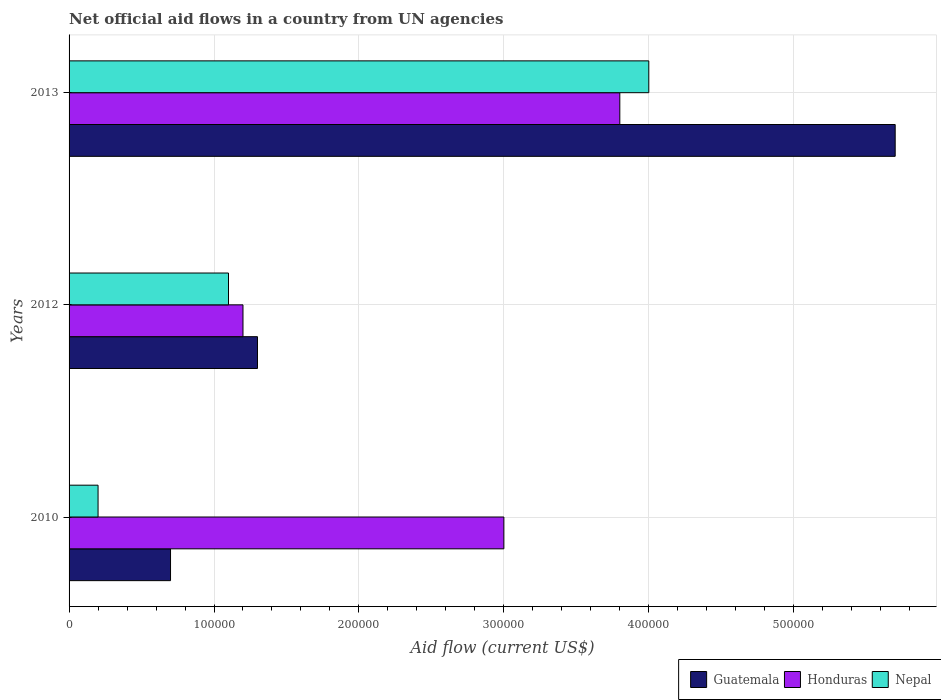How many different coloured bars are there?
Keep it short and to the point. 3. How many groups of bars are there?
Provide a short and direct response. 3. Are the number of bars on each tick of the Y-axis equal?
Give a very brief answer. Yes. How many bars are there on the 1st tick from the bottom?
Keep it short and to the point. 3. What is the label of the 2nd group of bars from the top?
Give a very brief answer. 2012. In how many cases, is the number of bars for a given year not equal to the number of legend labels?
Provide a succinct answer. 0. What is the net official aid flow in Guatemala in 2012?
Provide a short and direct response. 1.30e+05. Across all years, what is the maximum net official aid flow in Nepal?
Keep it short and to the point. 4.00e+05. Across all years, what is the minimum net official aid flow in Honduras?
Provide a short and direct response. 1.20e+05. In which year was the net official aid flow in Nepal maximum?
Your response must be concise. 2013. In which year was the net official aid flow in Honduras minimum?
Provide a short and direct response. 2012. What is the total net official aid flow in Honduras in the graph?
Your response must be concise. 8.00e+05. What is the difference between the net official aid flow in Guatemala in 2010 and that in 2013?
Your answer should be compact. -5.00e+05. What is the difference between the net official aid flow in Guatemala in 2010 and the net official aid flow in Honduras in 2012?
Your response must be concise. -5.00e+04. What is the average net official aid flow in Nepal per year?
Give a very brief answer. 1.77e+05. In the year 2013, what is the difference between the net official aid flow in Guatemala and net official aid flow in Honduras?
Provide a short and direct response. 1.90e+05. What is the ratio of the net official aid flow in Nepal in 2010 to that in 2012?
Offer a very short reply. 0.18. Is the difference between the net official aid flow in Guatemala in 2010 and 2012 greater than the difference between the net official aid flow in Honduras in 2010 and 2012?
Ensure brevity in your answer.  No. What is the difference between the highest and the second highest net official aid flow in Nepal?
Offer a very short reply. 2.90e+05. What is the difference between the highest and the lowest net official aid flow in Guatemala?
Offer a terse response. 5.00e+05. Is the sum of the net official aid flow in Honduras in 2010 and 2013 greater than the maximum net official aid flow in Nepal across all years?
Ensure brevity in your answer.  Yes. What does the 1st bar from the top in 2012 represents?
Your answer should be very brief. Nepal. What does the 1st bar from the bottom in 2010 represents?
Provide a short and direct response. Guatemala. How many bars are there?
Your response must be concise. 9. Are all the bars in the graph horizontal?
Make the answer very short. Yes. How many years are there in the graph?
Ensure brevity in your answer.  3. Are the values on the major ticks of X-axis written in scientific E-notation?
Your response must be concise. No. Does the graph contain any zero values?
Make the answer very short. No. Where does the legend appear in the graph?
Your answer should be very brief. Bottom right. How are the legend labels stacked?
Offer a terse response. Horizontal. What is the title of the graph?
Ensure brevity in your answer.  Net official aid flows in a country from UN agencies. What is the label or title of the Y-axis?
Keep it short and to the point. Years. What is the Aid flow (current US$) in Guatemala in 2010?
Make the answer very short. 7.00e+04. What is the Aid flow (current US$) in Guatemala in 2012?
Your answer should be very brief. 1.30e+05. What is the Aid flow (current US$) in Nepal in 2012?
Your response must be concise. 1.10e+05. What is the Aid flow (current US$) of Guatemala in 2013?
Provide a short and direct response. 5.70e+05. What is the Aid flow (current US$) in Nepal in 2013?
Give a very brief answer. 4.00e+05. Across all years, what is the maximum Aid flow (current US$) in Guatemala?
Your answer should be compact. 5.70e+05. Across all years, what is the maximum Aid flow (current US$) in Nepal?
Make the answer very short. 4.00e+05. Across all years, what is the minimum Aid flow (current US$) of Honduras?
Your response must be concise. 1.20e+05. What is the total Aid flow (current US$) of Guatemala in the graph?
Provide a short and direct response. 7.70e+05. What is the total Aid flow (current US$) of Nepal in the graph?
Your response must be concise. 5.30e+05. What is the difference between the Aid flow (current US$) in Honduras in 2010 and that in 2012?
Give a very brief answer. 1.80e+05. What is the difference between the Aid flow (current US$) in Nepal in 2010 and that in 2012?
Your response must be concise. -9.00e+04. What is the difference between the Aid flow (current US$) of Guatemala in 2010 and that in 2013?
Your answer should be compact. -5.00e+05. What is the difference between the Aid flow (current US$) of Honduras in 2010 and that in 2013?
Offer a terse response. -8.00e+04. What is the difference between the Aid flow (current US$) in Nepal in 2010 and that in 2013?
Your answer should be compact. -3.80e+05. What is the difference between the Aid flow (current US$) of Guatemala in 2012 and that in 2013?
Your answer should be very brief. -4.40e+05. What is the difference between the Aid flow (current US$) in Nepal in 2012 and that in 2013?
Make the answer very short. -2.90e+05. What is the difference between the Aid flow (current US$) in Guatemala in 2010 and the Aid flow (current US$) in Honduras in 2012?
Provide a short and direct response. -5.00e+04. What is the difference between the Aid flow (current US$) in Guatemala in 2010 and the Aid flow (current US$) in Nepal in 2012?
Offer a terse response. -4.00e+04. What is the difference between the Aid flow (current US$) of Guatemala in 2010 and the Aid flow (current US$) of Honduras in 2013?
Make the answer very short. -3.10e+05. What is the difference between the Aid flow (current US$) of Guatemala in 2010 and the Aid flow (current US$) of Nepal in 2013?
Give a very brief answer. -3.30e+05. What is the difference between the Aid flow (current US$) in Guatemala in 2012 and the Aid flow (current US$) in Honduras in 2013?
Provide a short and direct response. -2.50e+05. What is the difference between the Aid flow (current US$) in Guatemala in 2012 and the Aid flow (current US$) in Nepal in 2013?
Your answer should be very brief. -2.70e+05. What is the difference between the Aid flow (current US$) of Honduras in 2012 and the Aid flow (current US$) of Nepal in 2013?
Provide a succinct answer. -2.80e+05. What is the average Aid flow (current US$) in Guatemala per year?
Offer a terse response. 2.57e+05. What is the average Aid flow (current US$) of Honduras per year?
Make the answer very short. 2.67e+05. What is the average Aid flow (current US$) of Nepal per year?
Your answer should be compact. 1.77e+05. In the year 2010, what is the difference between the Aid flow (current US$) of Guatemala and Aid flow (current US$) of Honduras?
Ensure brevity in your answer.  -2.30e+05. In the year 2010, what is the difference between the Aid flow (current US$) of Guatemala and Aid flow (current US$) of Nepal?
Give a very brief answer. 5.00e+04. What is the ratio of the Aid flow (current US$) of Guatemala in 2010 to that in 2012?
Provide a short and direct response. 0.54. What is the ratio of the Aid flow (current US$) of Nepal in 2010 to that in 2012?
Give a very brief answer. 0.18. What is the ratio of the Aid flow (current US$) of Guatemala in 2010 to that in 2013?
Ensure brevity in your answer.  0.12. What is the ratio of the Aid flow (current US$) in Honduras in 2010 to that in 2013?
Offer a very short reply. 0.79. What is the ratio of the Aid flow (current US$) in Guatemala in 2012 to that in 2013?
Offer a terse response. 0.23. What is the ratio of the Aid flow (current US$) in Honduras in 2012 to that in 2013?
Keep it short and to the point. 0.32. What is the ratio of the Aid flow (current US$) in Nepal in 2012 to that in 2013?
Offer a very short reply. 0.28. What is the difference between the highest and the lowest Aid flow (current US$) of Guatemala?
Ensure brevity in your answer.  5.00e+05. What is the difference between the highest and the lowest Aid flow (current US$) in Honduras?
Your answer should be compact. 2.60e+05. 